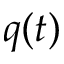Convert formula to latex. <formula><loc_0><loc_0><loc_500><loc_500>q ( t )</formula> 